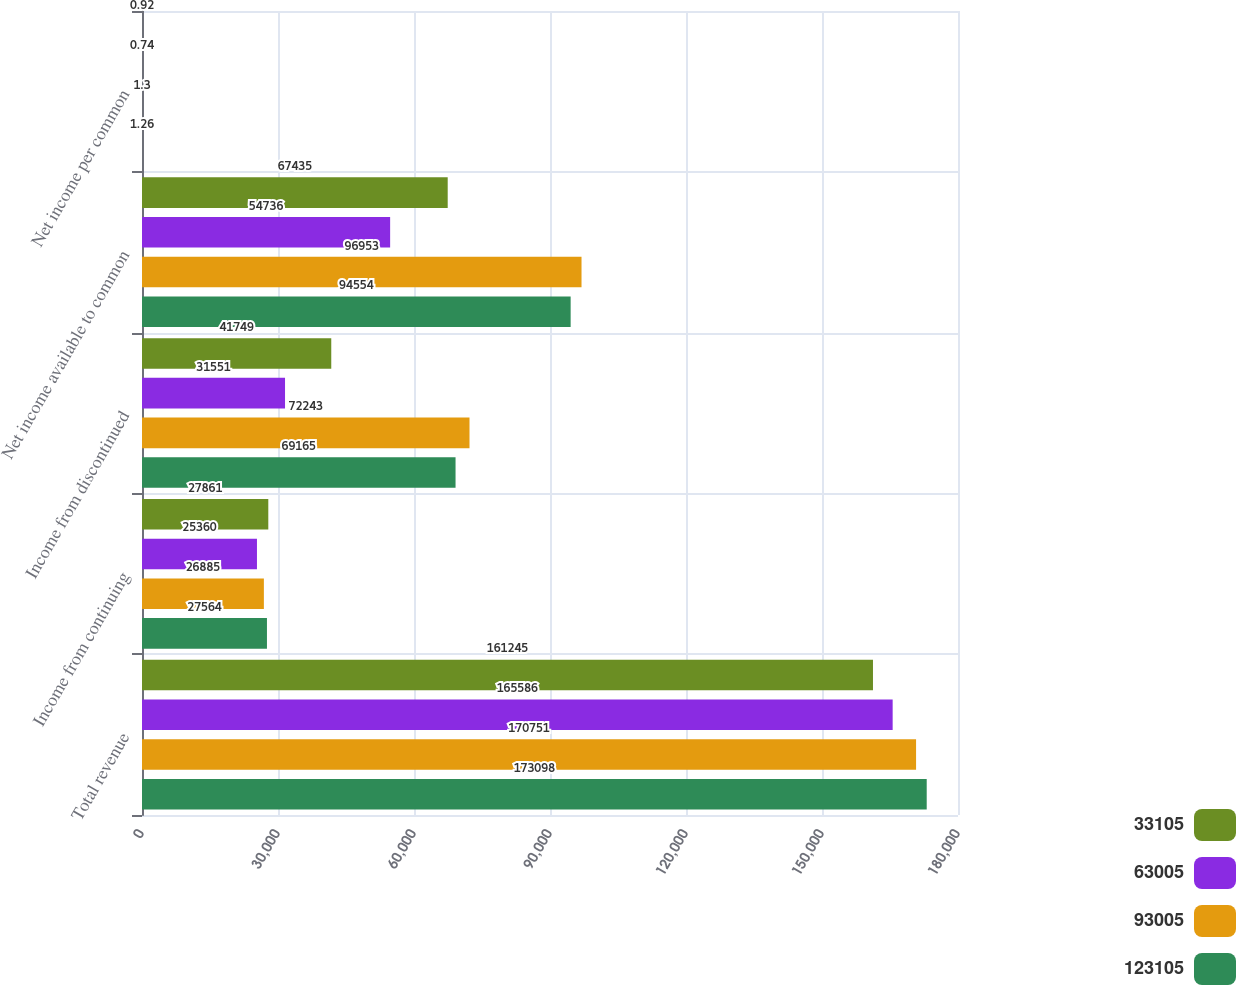Convert chart. <chart><loc_0><loc_0><loc_500><loc_500><stacked_bar_chart><ecel><fcel>Total revenue<fcel>Income from continuing<fcel>Income from discontinued<fcel>Net income available to common<fcel>Net income per common<nl><fcel>33105<fcel>161245<fcel>27861<fcel>41749<fcel>67435<fcel>0.92<nl><fcel>63005<fcel>165586<fcel>25360<fcel>31551<fcel>54736<fcel>0.74<nl><fcel>93005<fcel>170751<fcel>26885<fcel>72243<fcel>96953<fcel>1.3<nl><fcel>123105<fcel>173098<fcel>27564<fcel>69165<fcel>94554<fcel>1.26<nl></chart> 